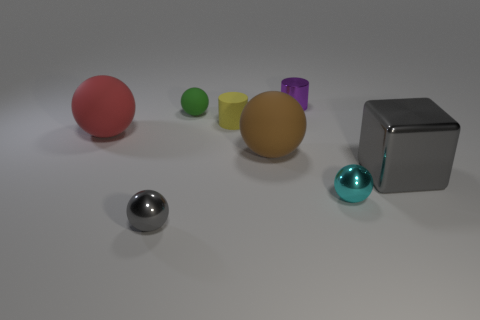Subtract all gray balls. How many balls are left? 4 Subtract all red rubber spheres. How many spheres are left? 4 Subtract all gray spheres. Subtract all gray blocks. How many spheres are left? 4 Add 1 green spheres. How many objects exist? 9 Subtract all cubes. How many objects are left? 7 Subtract all big cyan objects. Subtract all tiny objects. How many objects are left? 3 Add 2 small yellow objects. How many small yellow objects are left? 3 Add 6 yellow things. How many yellow things exist? 7 Subtract 1 brown balls. How many objects are left? 7 